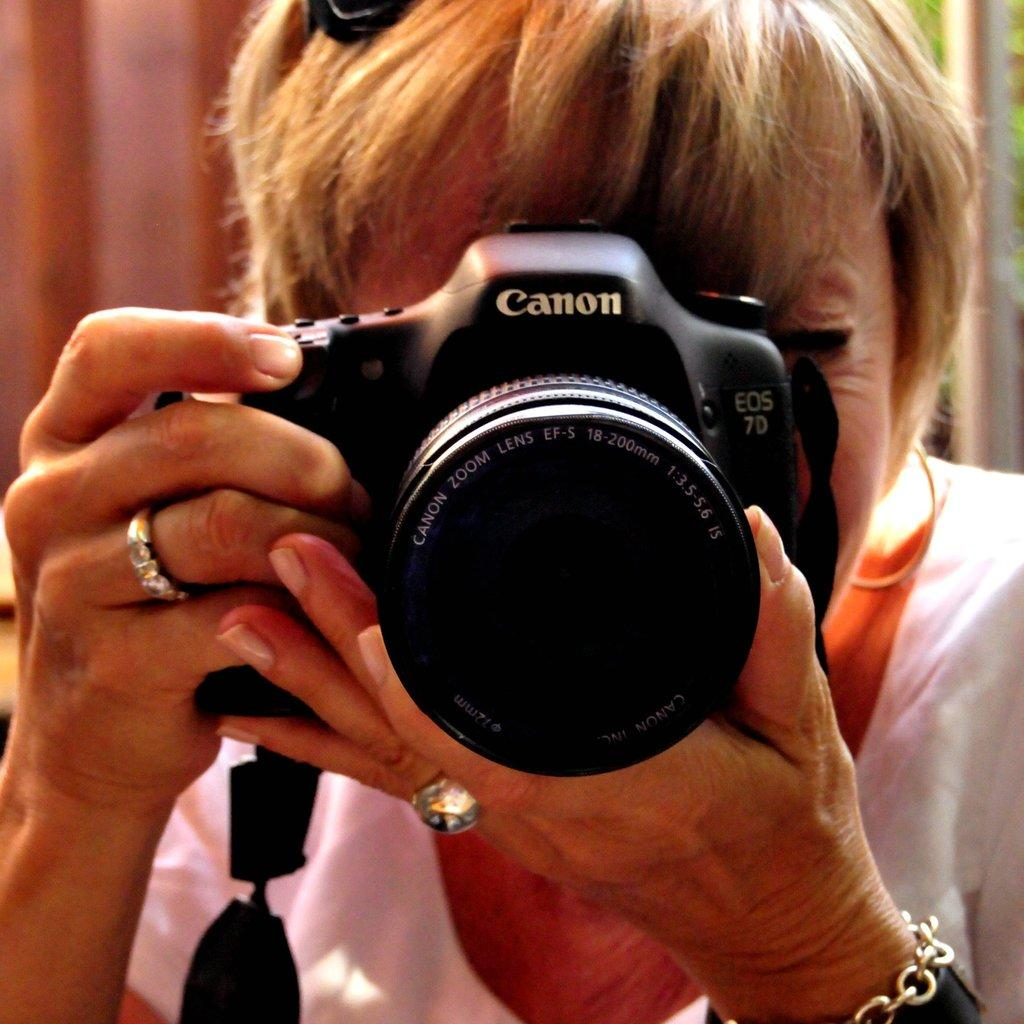Who is the main subject in the image? There is an old woman in the image. What is the old woman holding? The woman is holding a camera. Are there any accessories on her hands? Yes, there is a ring on each of her hands, and there is a chain on her left hand. Can you tell me how long the fight between the old woman and the river lasted in the image? There is no river or fight present in the image; it features an old woman holding a camera and wearing rings and a chain on her hands. 